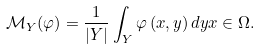<formula> <loc_0><loc_0><loc_500><loc_500>\mathcal { M } _ { Y } ( { \varphi } ) = \frac { 1 } { \left | Y \right | } \int _ { Y } { \varphi } \left ( x , y \right ) d y x \in \Omega .</formula> 